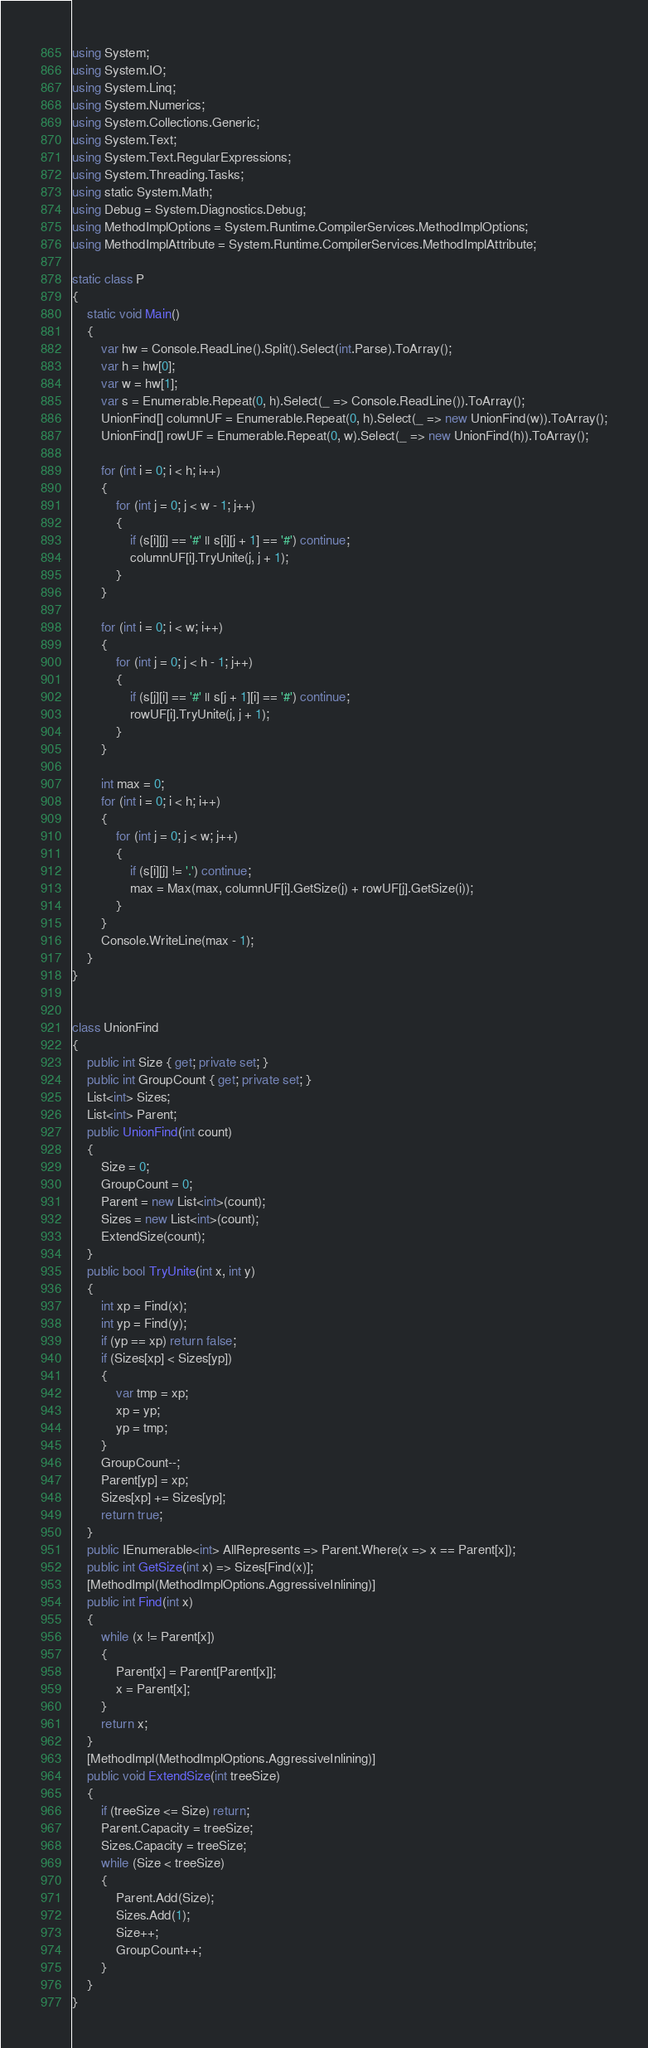Convert code to text. <code><loc_0><loc_0><loc_500><loc_500><_C#_>using System;
using System.IO;
using System.Linq;
using System.Numerics;
using System.Collections.Generic;
using System.Text;
using System.Text.RegularExpressions;
using System.Threading.Tasks;
using static System.Math;
using Debug = System.Diagnostics.Debug;
using MethodImplOptions = System.Runtime.CompilerServices.MethodImplOptions;
using MethodImplAttribute = System.Runtime.CompilerServices.MethodImplAttribute;

static class P
{
    static void Main()
    {
        var hw = Console.ReadLine().Split().Select(int.Parse).ToArray();
        var h = hw[0];
        var w = hw[1];
        var s = Enumerable.Repeat(0, h).Select(_ => Console.ReadLine()).ToArray();
        UnionFind[] columnUF = Enumerable.Repeat(0, h).Select(_ => new UnionFind(w)).ToArray();
        UnionFind[] rowUF = Enumerable.Repeat(0, w).Select(_ => new UnionFind(h)).ToArray();

        for (int i = 0; i < h; i++)
        {
            for (int j = 0; j < w - 1; j++)
            {
                if (s[i][j] == '#' || s[i][j + 1] == '#') continue;
                columnUF[i].TryUnite(j, j + 1);
            }
        }

        for (int i = 0; i < w; i++)
        {
            for (int j = 0; j < h - 1; j++)
            {
                if (s[j][i] == '#' || s[j + 1][i] == '#') continue;
                rowUF[i].TryUnite(j, j + 1);
            }
        }

        int max = 0;
        for (int i = 0; i < h; i++)
        {
            for (int j = 0; j < w; j++)
            {
                if (s[i][j] != '.') continue;
                max = Max(max, columnUF[i].GetSize(j) + rowUF[j].GetSize(i));
            }
        }
        Console.WriteLine(max - 1);
    }
}


class UnionFind
{
    public int Size { get; private set; }
    public int GroupCount { get; private set; }
    List<int> Sizes;
    List<int> Parent;
    public UnionFind(int count)
    {
        Size = 0;
        GroupCount = 0;
        Parent = new List<int>(count);
        Sizes = new List<int>(count);
        ExtendSize(count);
    }
    public bool TryUnite(int x, int y)
    {
        int xp = Find(x);
        int yp = Find(y);
        if (yp == xp) return false;
        if (Sizes[xp] < Sizes[yp])
        {
            var tmp = xp;
            xp = yp;
            yp = tmp;
        }
        GroupCount--;
        Parent[yp] = xp;
        Sizes[xp] += Sizes[yp];
        return true;
    }
    public IEnumerable<int> AllRepresents => Parent.Where(x => x == Parent[x]);
    public int GetSize(int x) => Sizes[Find(x)];
    [MethodImpl(MethodImplOptions.AggressiveInlining)]
    public int Find(int x)
    {
        while (x != Parent[x])
        {
            Parent[x] = Parent[Parent[x]];
            x = Parent[x];
        }
        return x;
    }
    [MethodImpl(MethodImplOptions.AggressiveInlining)]
    public void ExtendSize(int treeSize)
    {
        if (treeSize <= Size) return;
        Parent.Capacity = treeSize;
        Sizes.Capacity = treeSize;
        while (Size < treeSize)
        {
            Parent.Add(Size);
            Sizes.Add(1);
            Size++;
            GroupCount++;
        }
    }
}</code> 